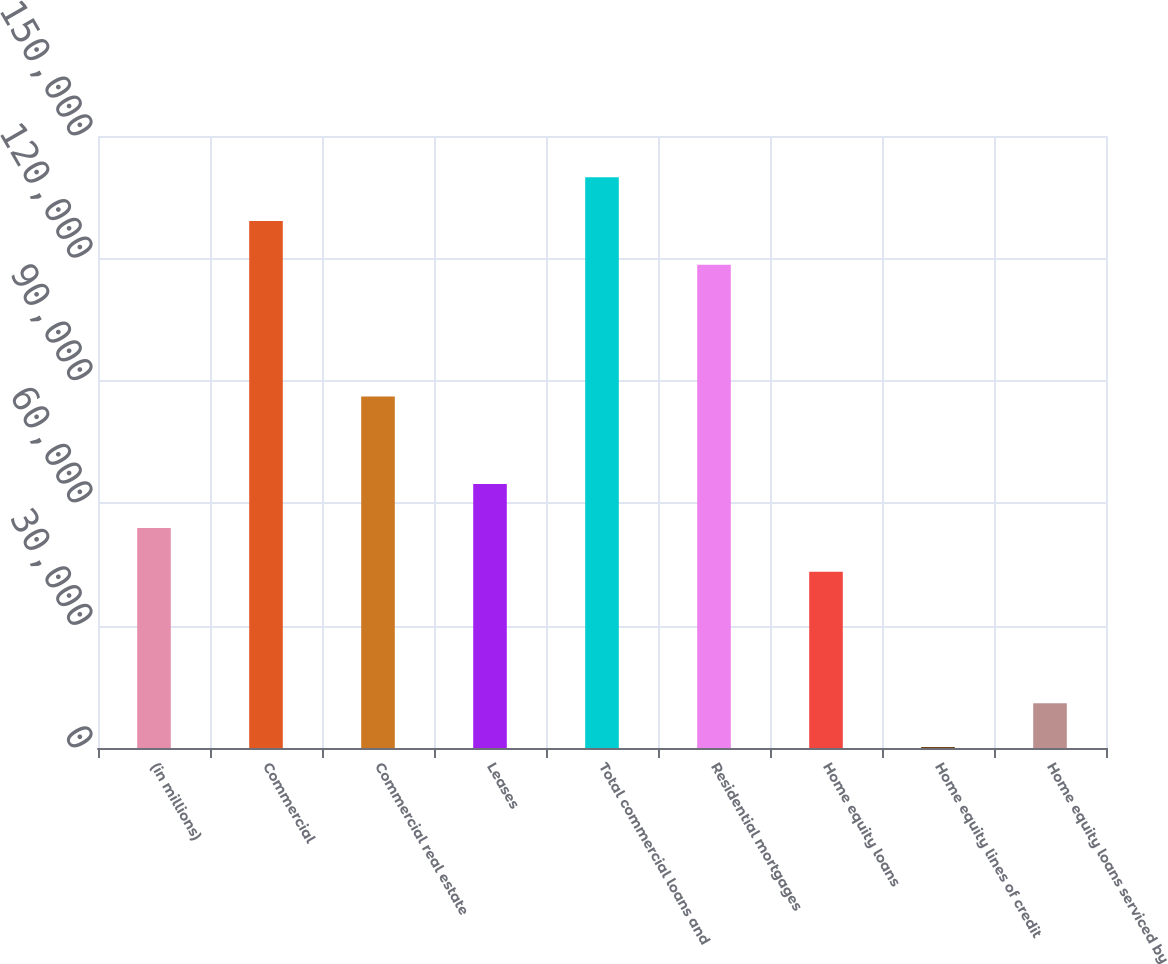Convert chart to OTSL. <chart><loc_0><loc_0><loc_500><loc_500><bar_chart><fcel>(in millions)<fcel>Commercial<fcel>Commercial real estate<fcel>Leases<fcel>Total commercial loans and<fcel>Residential mortgages<fcel>Home equity loans<fcel>Home equity lines of credit<fcel>Home equity loans serviced by<nl><fcel>53944<fcel>129159<fcel>86179<fcel>64689<fcel>139904<fcel>118414<fcel>43199<fcel>219<fcel>10964<nl></chart> 